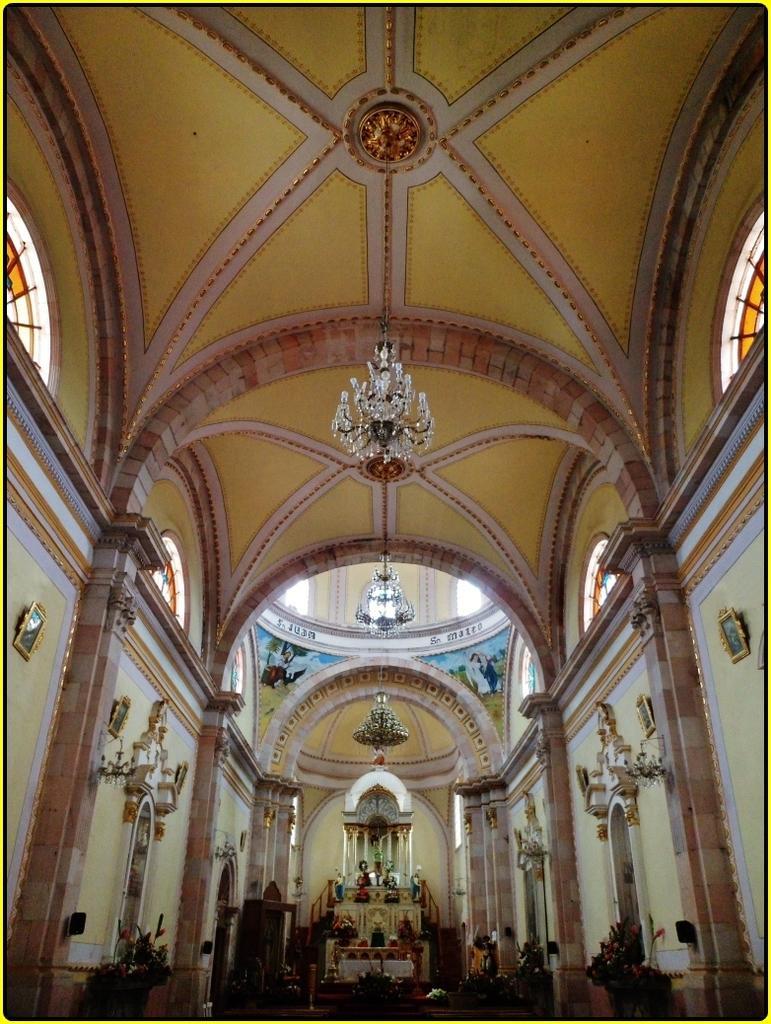Could you give a brief overview of what you see in this image? This image is taken in the hall. In the center we can see an alter. At the top there are chandeliers and there are walls. We can see frames placed on the walls and there is a painting on the wall. There are stained glasses. 